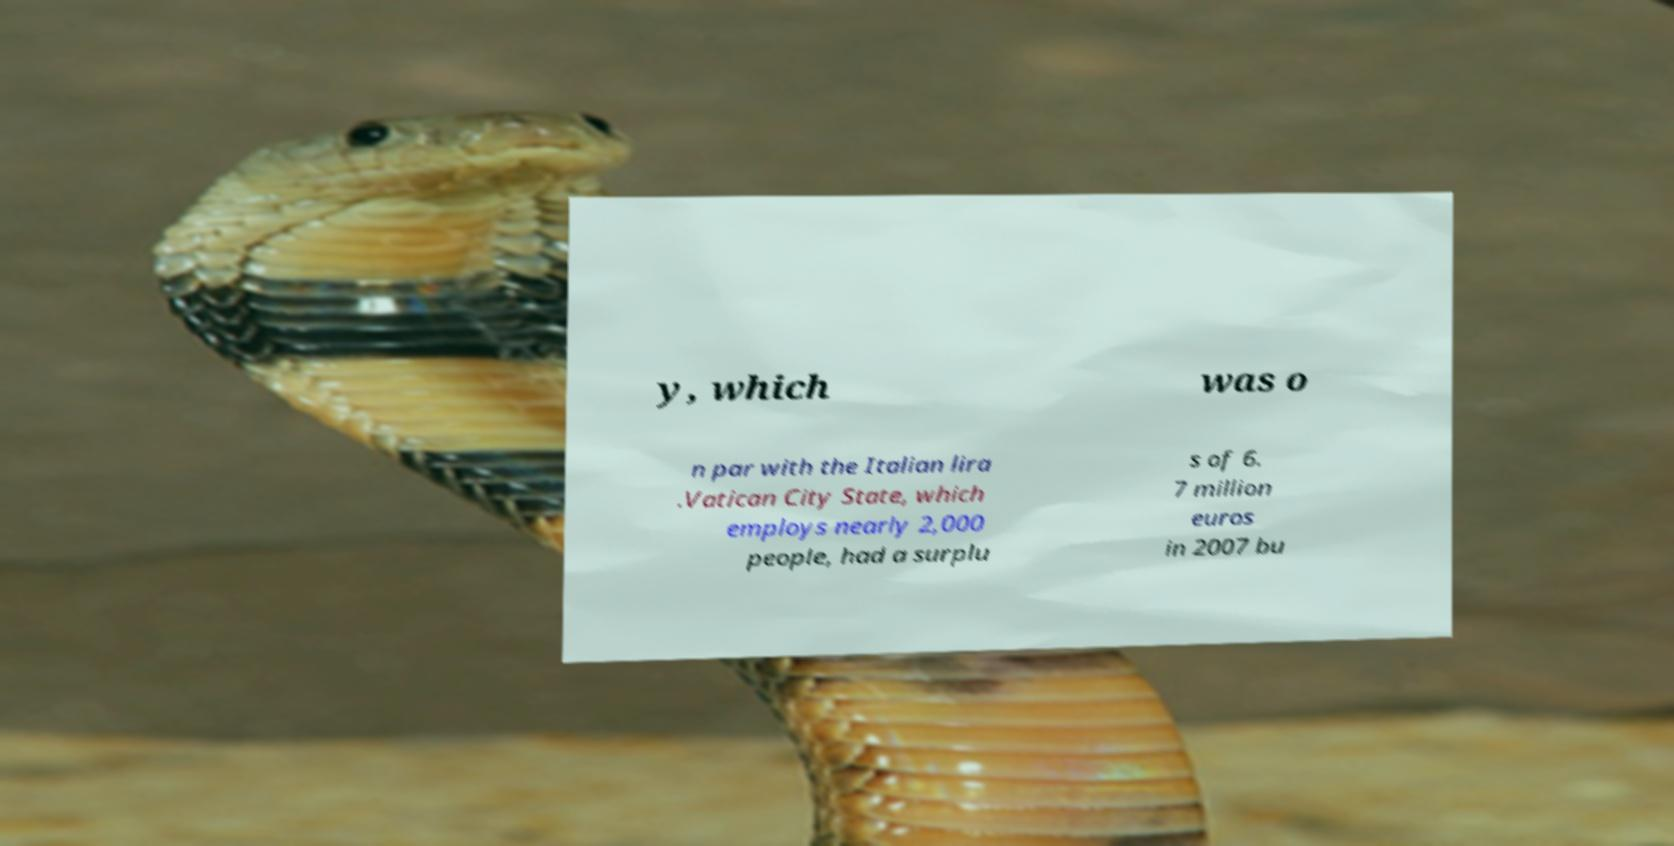Please read and relay the text visible in this image. What does it say? y, which was o n par with the Italian lira .Vatican City State, which employs nearly 2,000 people, had a surplu s of 6. 7 million euros in 2007 bu 